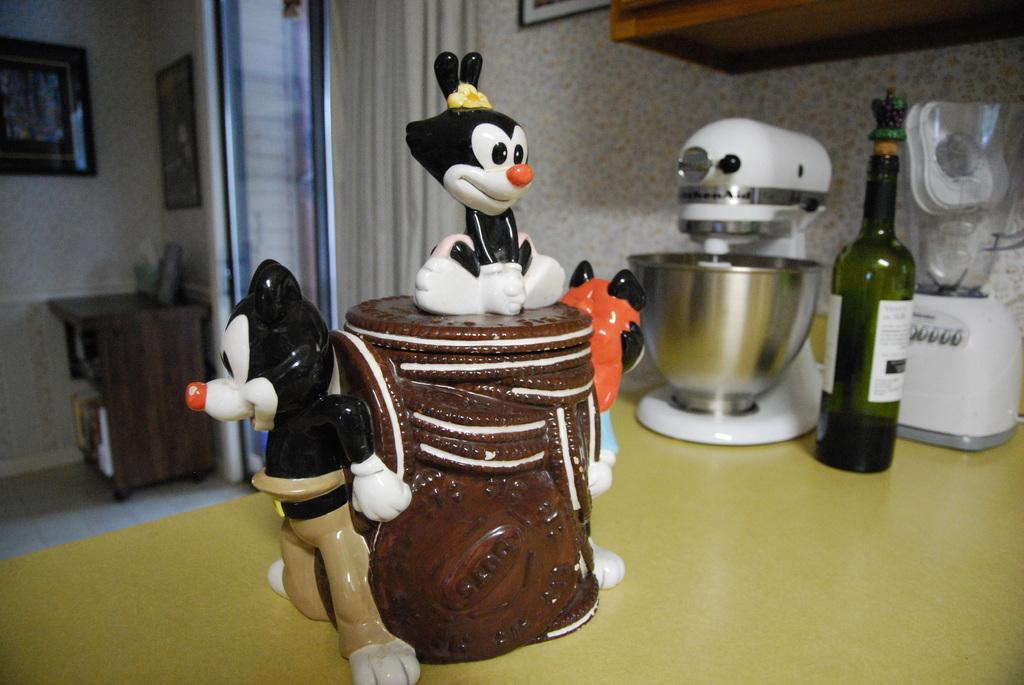What is the main object on the table in the image? There is a cake on the table. What other items can be seen on the table? There are two mixers and a bottle on the table. Is there any decorative element in the image? Yes, there is a frame at the back side of the image. What type of chicken is depicted in the frame at the back side of the image? There is no chicken present in the image, as the frame contains a different subject or design. 